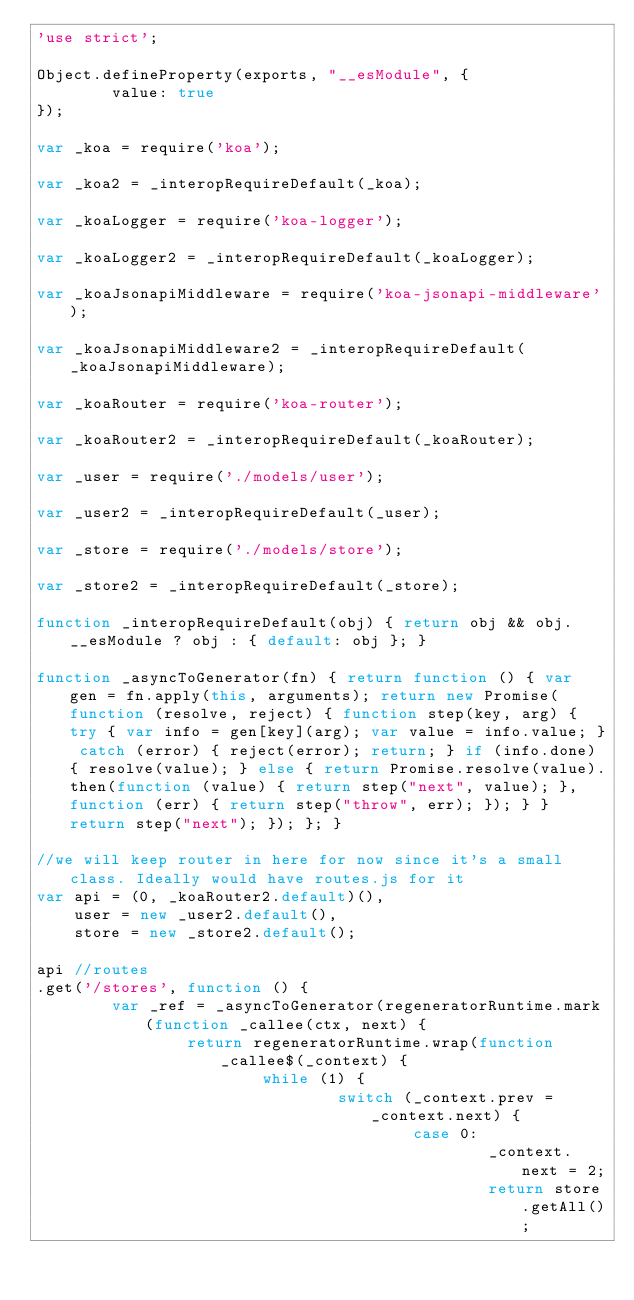Convert code to text. <code><loc_0><loc_0><loc_500><loc_500><_JavaScript_>'use strict';

Object.defineProperty(exports, "__esModule", {
		value: true
});

var _koa = require('koa');

var _koa2 = _interopRequireDefault(_koa);

var _koaLogger = require('koa-logger');

var _koaLogger2 = _interopRequireDefault(_koaLogger);

var _koaJsonapiMiddleware = require('koa-jsonapi-middleware');

var _koaJsonapiMiddleware2 = _interopRequireDefault(_koaJsonapiMiddleware);

var _koaRouter = require('koa-router');

var _koaRouter2 = _interopRequireDefault(_koaRouter);

var _user = require('./models/user');

var _user2 = _interopRequireDefault(_user);

var _store = require('./models/store');

var _store2 = _interopRequireDefault(_store);

function _interopRequireDefault(obj) { return obj && obj.__esModule ? obj : { default: obj }; }

function _asyncToGenerator(fn) { return function () { var gen = fn.apply(this, arguments); return new Promise(function (resolve, reject) { function step(key, arg) { try { var info = gen[key](arg); var value = info.value; } catch (error) { reject(error); return; } if (info.done) { resolve(value); } else { return Promise.resolve(value).then(function (value) { return step("next", value); }, function (err) { return step("throw", err); }); } } return step("next"); }); }; }

//we will keep router in here for now since it's a small class. Ideally would have routes.js for it
var api = (0, _koaRouter2.default)(),
    user = new _user2.default(),
    store = new _store2.default();

api //routes
.get('/stores', function () {
		var _ref = _asyncToGenerator(regeneratorRuntime.mark(function _callee(ctx, next) {
				return regeneratorRuntime.wrap(function _callee$(_context) {
						while (1) {
								switch (_context.prev = _context.next) {
										case 0:
												_context.next = 2;
												return store.getAll();
</code> 